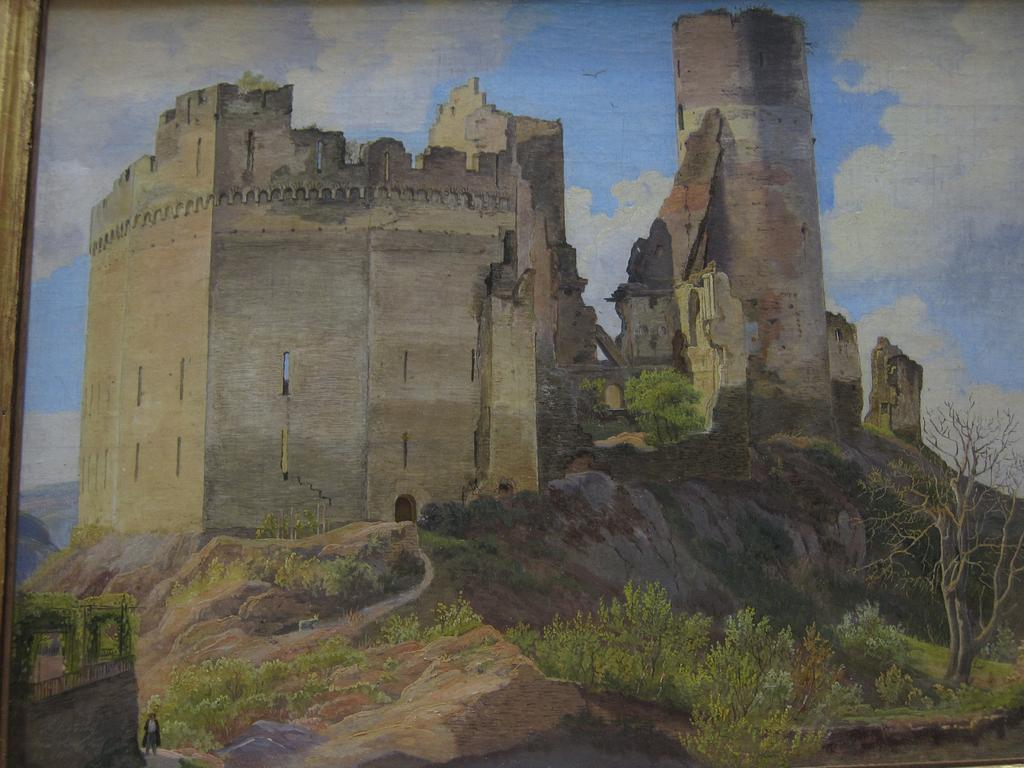What is depicted in the painting in the image? There is a painting of a fort in the image. What type of natural elements can be seen in the image? There are trees and plants in the image. What is present in the background of the image? There is a bird and the sky visible in the background of the image. Can you describe the person in the image? There is a person standing in the image. What type of advertisement can be seen on the fort in the image? There is no advertisement present on the fort in the image; it is a painting of a fort. How many snails are crawling on the person in the image? There are no snails present in the image, and the person is not interacting with any snails. 